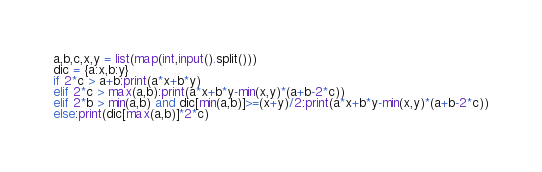<code> <loc_0><loc_0><loc_500><loc_500><_Python_>a,b,c,x,y = list(map(int,input().split()))
dic = {a:x,b:y}
if 2*c > a+b:print(a*x+b*y)
elif 2*c > max(a,b):print(a*x+b*y-min(x,y)*(a+b-2*c))
elif 2*b > min(a,b) and dic[min(a,b)]>=(x+y)/2:print(a*x+b*y-min(x,y)*(a+b-2*c))
else:print(dic[max(a,b)]*2*c)
</code> 